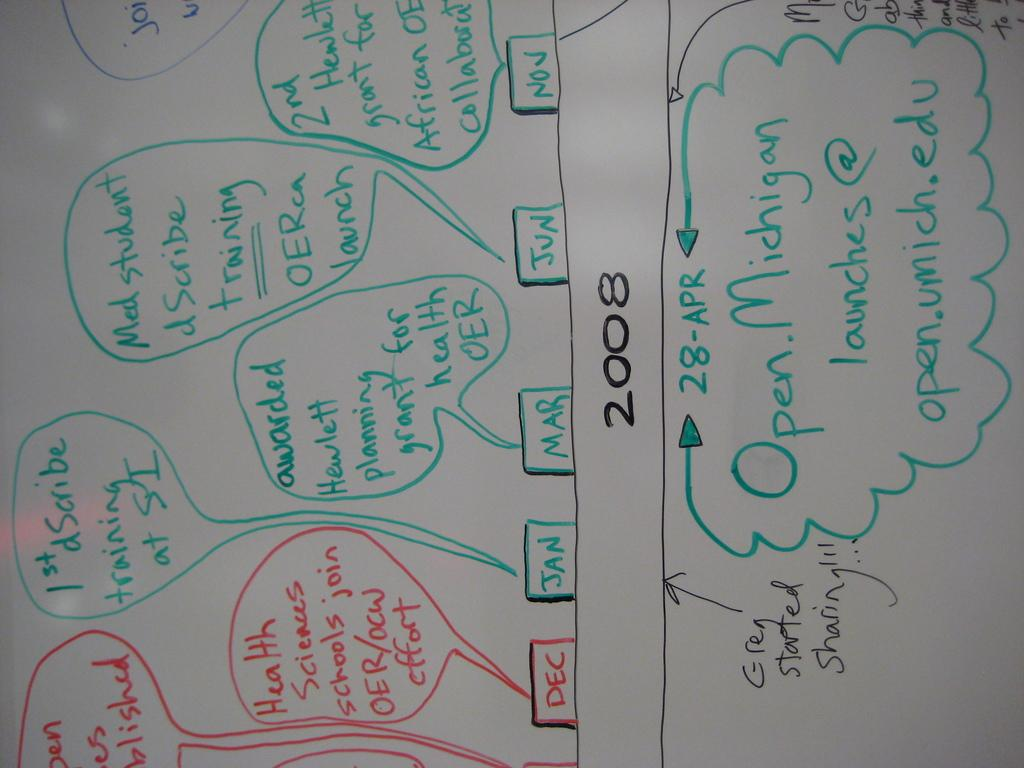<image>
Present a compact description of the photo's key features. A white board has hand written notes and the year 2008. 